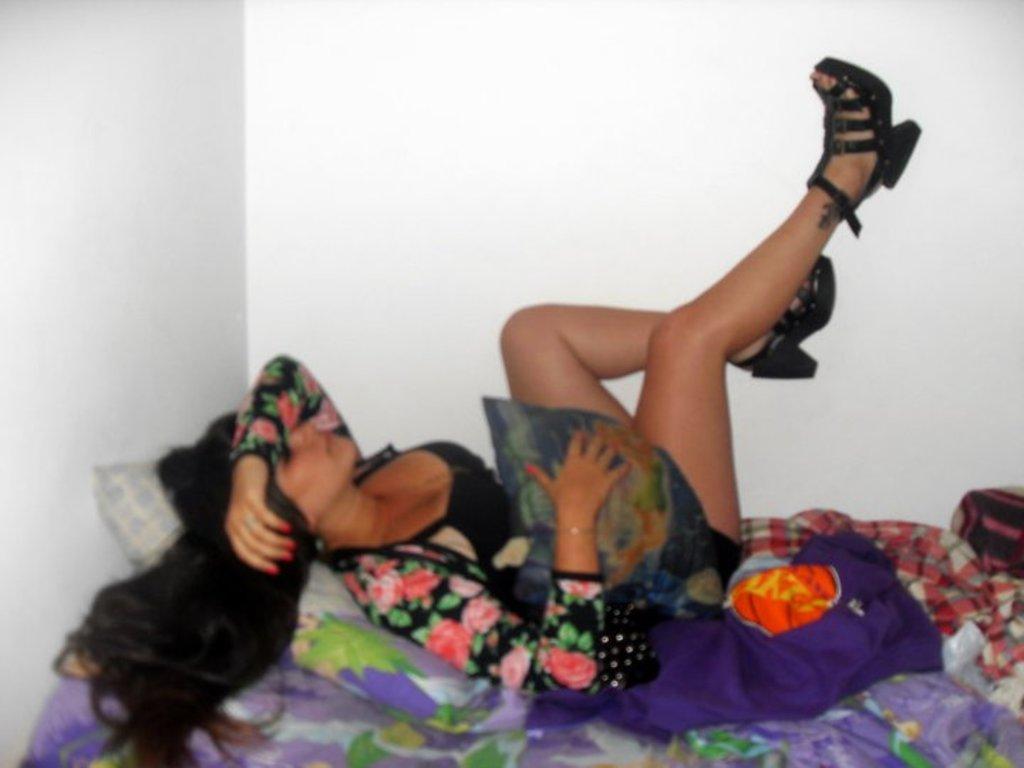How would you summarize this image in a sentence or two? In this image, we can see a person on the bed which is beside the wall. This person is wearing clothes and footwear. 